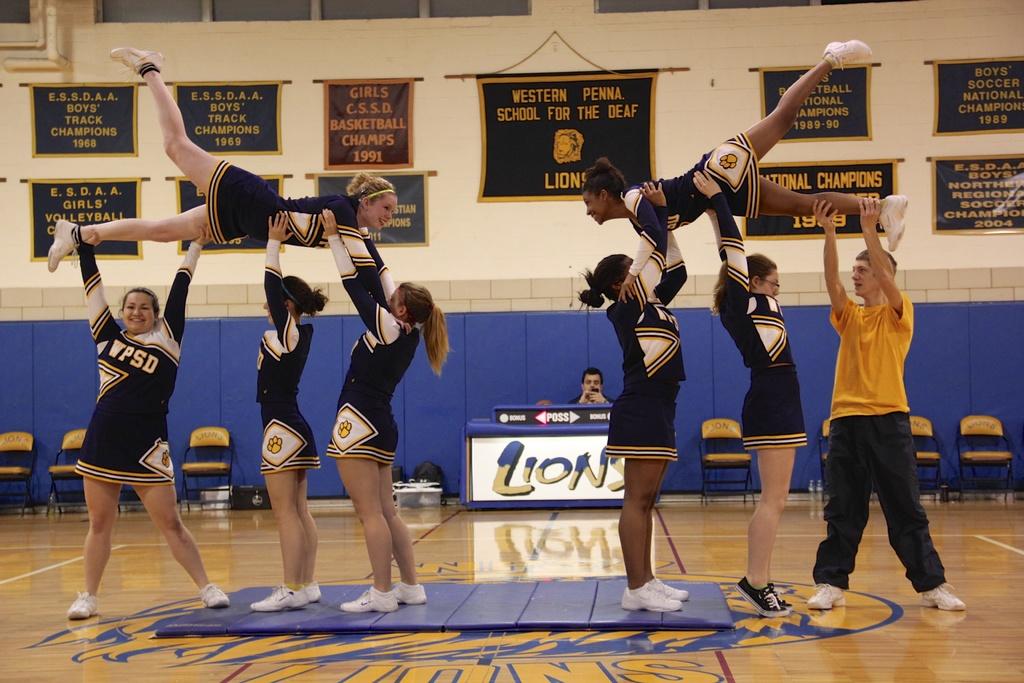What is the mascot for western pemna. school for the deaf?
Give a very brief answer. Lions. What is the team name?
Your answer should be compact. Lions. 